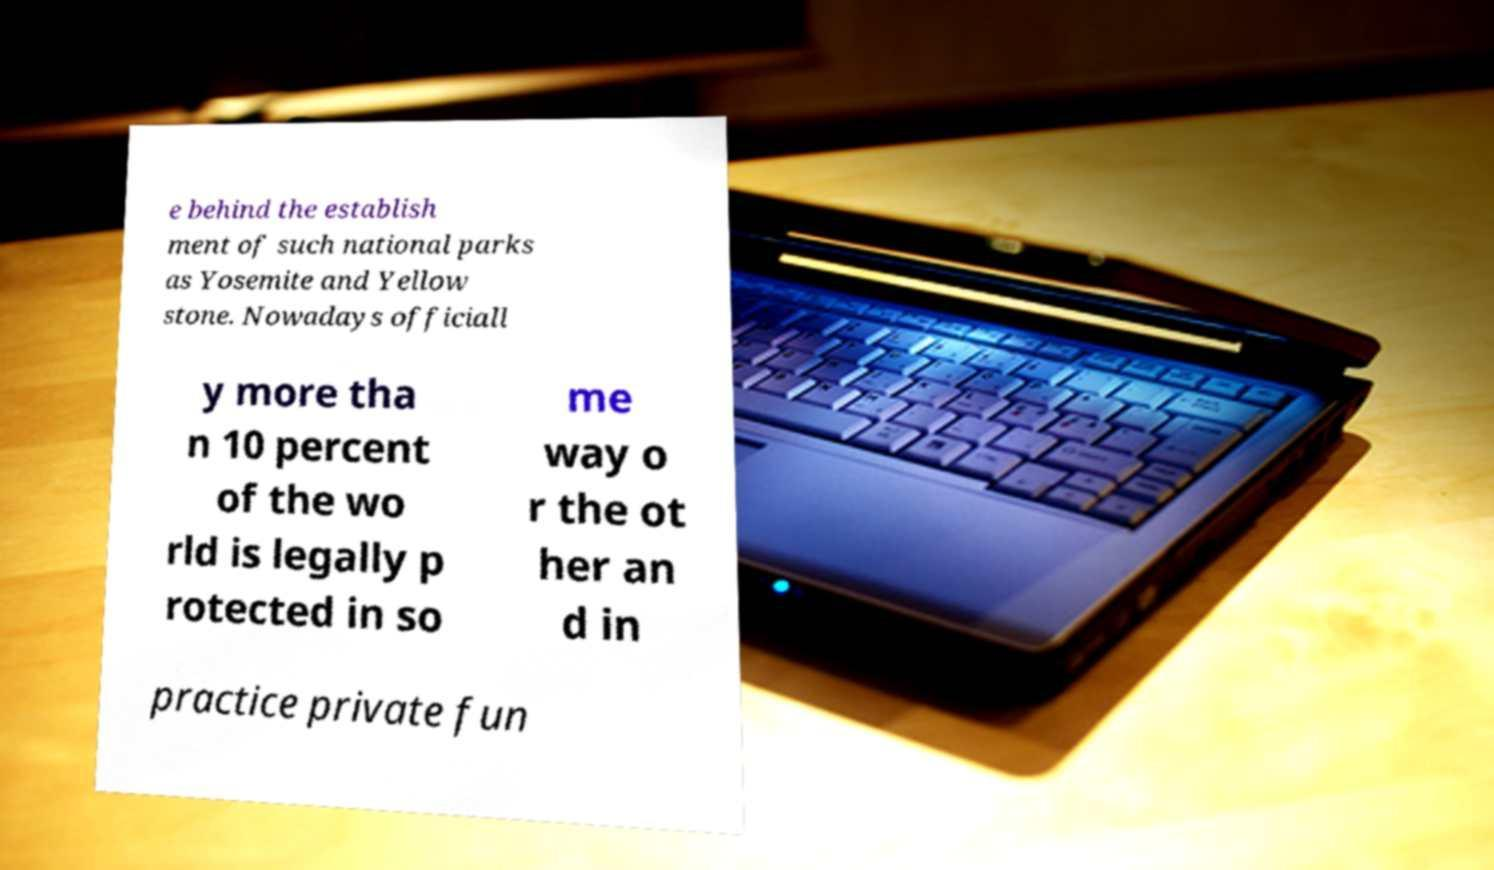There's text embedded in this image that I need extracted. Can you transcribe it verbatim? e behind the establish ment of such national parks as Yosemite and Yellow stone. Nowadays officiall y more tha n 10 percent of the wo rld is legally p rotected in so me way o r the ot her an d in practice private fun 